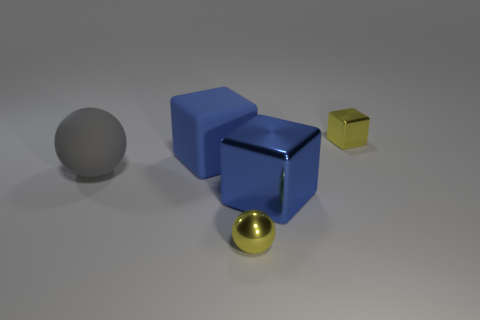Subtract 1 cubes. How many cubes are left? 2 Subtract all big cubes. How many cubes are left? 1 Subtract all brown cylinders. How many blue blocks are left? 2 Add 3 large red metallic balls. How many objects exist? 8 Subtract all cubes. How many objects are left? 2 Subtract all small spheres. Subtract all matte cylinders. How many objects are left? 4 Add 4 big gray rubber objects. How many big gray rubber objects are left? 5 Add 2 metal cubes. How many metal cubes exist? 4 Subtract 2 blue cubes. How many objects are left? 3 